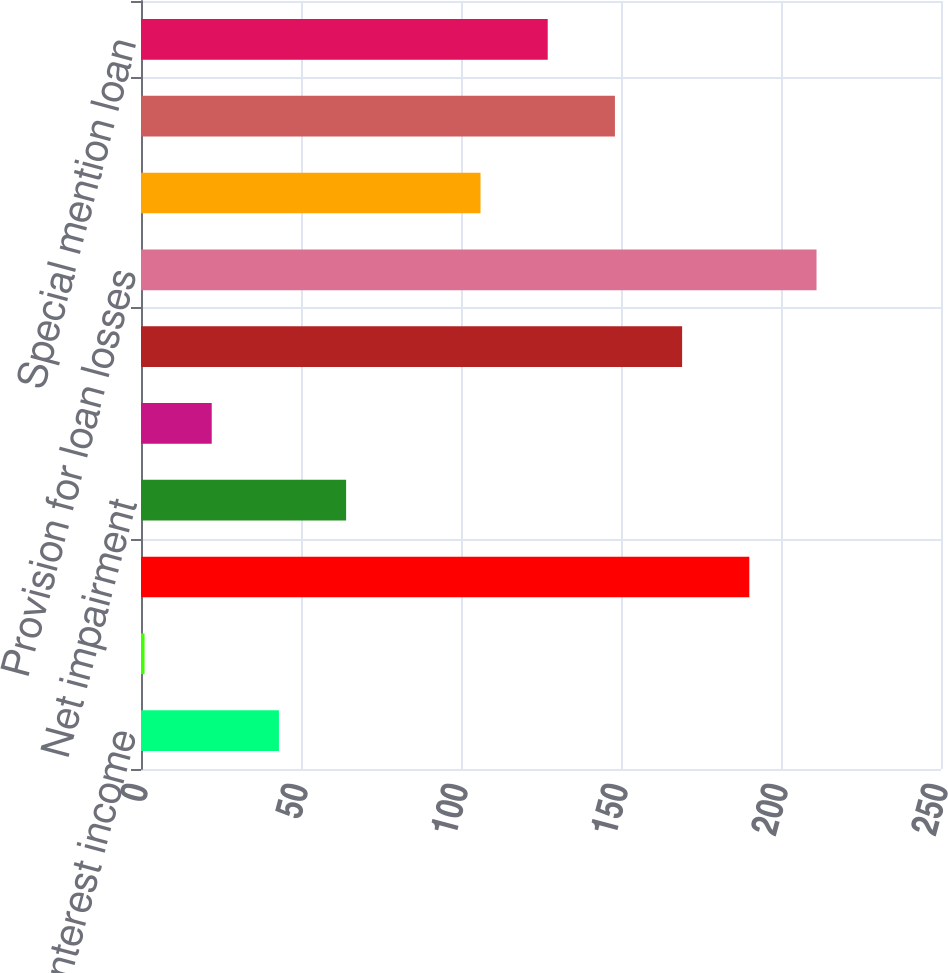Convert chart. <chart><loc_0><loc_0><loc_500><loc_500><bar_chart><fcel>Net operating interest income<fcel>Fees and service charges<fcel>Gains on loans and securities<fcel>Net impairment<fcel>Other revenues<fcel>Total net revenue<fcel>Provision for loan losses<fcel>Total operating expense<fcel>Balance sheet management<fcel>Special mention loan<nl><fcel>43.1<fcel>1.1<fcel>190.1<fcel>64.1<fcel>22.1<fcel>169.1<fcel>211.1<fcel>106.1<fcel>148.1<fcel>127.1<nl></chart> 